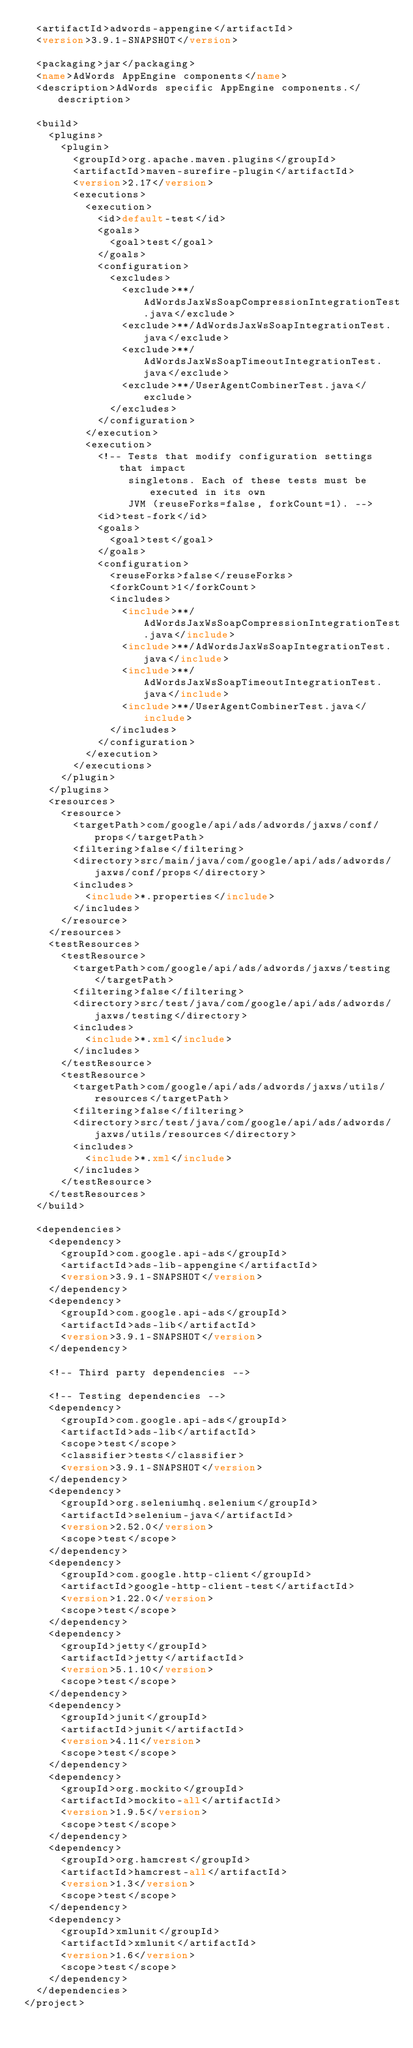Convert code to text. <code><loc_0><loc_0><loc_500><loc_500><_XML_>  <artifactId>adwords-appengine</artifactId>
  <version>3.9.1-SNAPSHOT</version>

  <packaging>jar</packaging>
  <name>AdWords AppEngine components</name>
  <description>AdWords specific AppEngine components.</description>

  <build>
    <plugins>
      <plugin>
        <groupId>org.apache.maven.plugins</groupId>
        <artifactId>maven-surefire-plugin</artifactId>
        <version>2.17</version>
        <executions>
          <execution>
            <id>default-test</id>
            <goals>
              <goal>test</goal>
            </goals>
            <configuration>
              <excludes>
                <exclude>**/AdWordsJaxWsSoapCompressionIntegrationTest.java</exclude>
                <exclude>**/AdWordsJaxWsSoapIntegrationTest.java</exclude>
                <exclude>**/AdWordsJaxWsSoapTimeoutIntegrationTest.java</exclude>
                <exclude>**/UserAgentCombinerTest.java</exclude>
              </excludes>
            </configuration>
          </execution>
          <execution>
            <!-- Tests that modify configuration settings that impact
                 singletons. Each of these tests must be executed in its own
                 JVM (reuseForks=false, forkCount=1). -->
            <id>test-fork</id>
            <goals>
              <goal>test</goal>
            </goals>
            <configuration>
              <reuseForks>false</reuseForks>
              <forkCount>1</forkCount>
              <includes>
                <include>**/AdWordsJaxWsSoapCompressionIntegrationTest.java</include>
                <include>**/AdWordsJaxWsSoapIntegrationTest.java</include>
                <include>**/AdWordsJaxWsSoapTimeoutIntegrationTest.java</include>
                <include>**/UserAgentCombinerTest.java</include>
              </includes>
            </configuration>
          </execution>
        </executions>
      </plugin>
    </plugins>
    <resources>
      <resource>
        <targetPath>com/google/api/ads/adwords/jaxws/conf/props</targetPath>
        <filtering>false</filtering>
        <directory>src/main/java/com/google/api/ads/adwords/jaxws/conf/props</directory>
        <includes>
          <include>*.properties</include>
        </includes>
      </resource>
    </resources>
    <testResources>
      <testResource>
        <targetPath>com/google/api/ads/adwords/jaxws/testing</targetPath>
        <filtering>false</filtering>
        <directory>src/test/java/com/google/api/ads/adwords/jaxws/testing</directory>
        <includes>
          <include>*.xml</include>
        </includes>
      </testResource>
      <testResource>
        <targetPath>com/google/api/ads/adwords/jaxws/utils/resources</targetPath>
        <filtering>false</filtering>
        <directory>src/test/java/com/google/api/ads/adwords/jaxws/utils/resources</directory>
        <includes>
          <include>*.xml</include>
        </includes>
      </testResource>
    </testResources>
  </build>

  <dependencies>
    <dependency>
      <groupId>com.google.api-ads</groupId>
      <artifactId>ads-lib-appengine</artifactId>
      <version>3.9.1-SNAPSHOT</version>
    </dependency>
    <dependency>
      <groupId>com.google.api-ads</groupId>
      <artifactId>ads-lib</artifactId>
      <version>3.9.1-SNAPSHOT</version>
    </dependency>

    <!-- Third party dependencies -->

    <!-- Testing dependencies -->
    <dependency>
      <groupId>com.google.api-ads</groupId>
      <artifactId>ads-lib</artifactId>
      <scope>test</scope>
      <classifier>tests</classifier>
      <version>3.9.1-SNAPSHOT</version>
    </dependency>
    <dependency>
      <groupId>org.seleniumhq.selenium</groupId>
      <artifactId>selenium-java</artifactId>
      <version>2.52.0</version>
      <scope>test</scope>
    </dependency>
    <dependency>
      <groupId>com.google.http-client</groupId>
      <artifactId>google-http-client-test</artifactId>
      <version>1.22.0</version>
      <scope>test</scope>
    </dependency>
    <dependency>
      <groupId>jetty</groupId>
      <artifactId>jetty</artifactId>
      <version>5.1.10</version>
      <scope>test</scope>
    </dependency>
    <dependency>
      <groupId>junit</groupId>
      <artifactId>junit</artifactId>
      <version>4.11</version>
      <scope>test</scope>
    </dependency>
    <dependency>
      <groupId>org.mockito</groupId>
      <artifactId>mockito-all</artifactId>
      <version>1.9.5</version>
      <scope>test</scope>
    </dependency>
    <dependency>
      <groupId>org.hamcrest</groupId>
      <artifactId>hamcrest-all</artifactId>
      <version>1.3</version>
      <scope>test</scope>
    </dependency>
    <dependency>
      <groupId>xmlunit</groupId>
      <artifactId>xmlunit</artifactId>
      <version>1.6</version>
      <scope>test</scope>
    </dependency>
  </dependencies>
</project>
</code> 